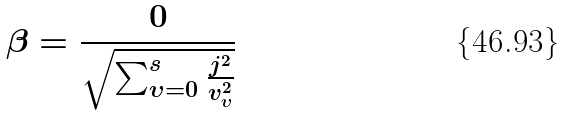<formula> <loc_0><loc_0><loc_500><loc_500>\beta = \frac { 0 } { \sqrt { \sum _ { \upsilon = 0 } ^ { s } \frac { j ^ { 2 } } { v _ { \upsilon } ^ { 2 } } } }</formula> 